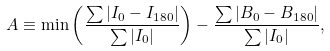Convert formula to latex. <formula><loc_0><loc_0><loc_500><loc_500>A \equiv \min \left ( \frac { \sum | I _ { 0 } - I _ { 1 8 0 } | } { \sum | I _ { 0 } | } \right ) - \frac { \sum | B _ { 0 } - B _ { 1 8 0 } | } { \sum | I _ { 0 } | } ,</formula> 